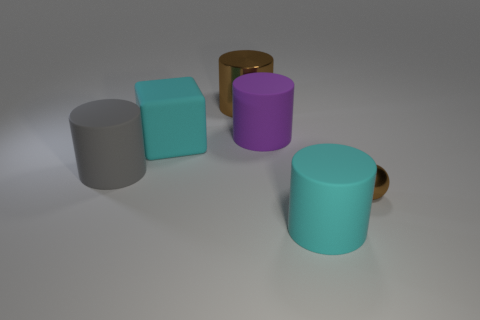There is a brown sphere that is the same material as the brown cylinder; what size is it?
Give a very brief answer. Small. Do the gray matte thing that is in front of the purple rubber cylinder and the big block have the same size?
Your answer should be very brief. Yes. There is a matte thing on the left side of the big cyan thing to the left of the thing in front of the brown metallic ball; what shape is it?
Offer a terse response. Cylinder. What number of things are either gray objects or matte cylinders that are on the right side of the large brown object?
Ensure brevity in your answer.  3. What is the size of the thing to the right of the big cyan matte cylinder?
Make the answer very short. Small. There is a matte object that is the same color as the big block; what is its shape?
Provide a short and direct response. Cylinder. Is the tiny object made of the same material as the big cyan object in front of the brown shiny ball?
Ensure brevity in your answer.  No. How many large things are behind the big cyan matte object on the right side of the big rubber object behind the cyan matte cube?
Provide a succinct answer. 4. How many brown objects are objects or blocks?
Keep it short and to the point. 2. There is a shiny thing in front of the big brown shiny thing; what shape is it?
Your response must be concise. Sphere. 